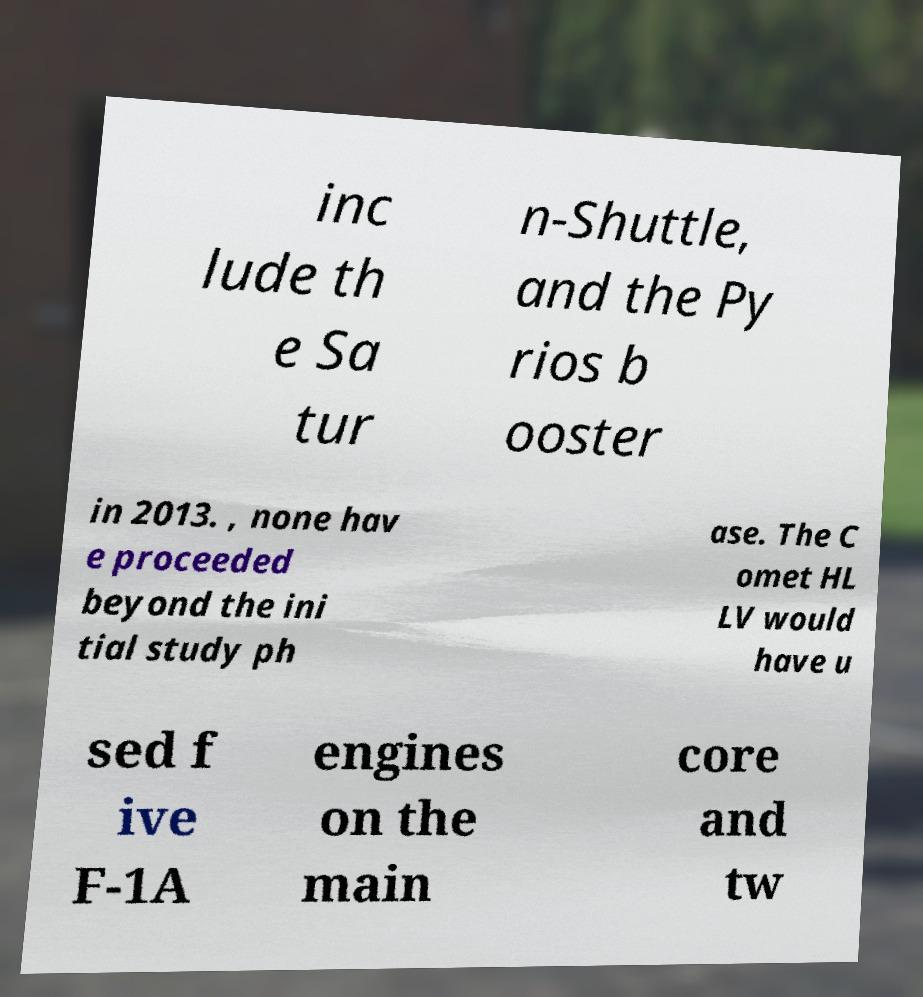I need the written content from this picture converted into text. Can you do that? inc lude th e Sa tur n-Shuttle, and the Py rios b ooster in 2013. , none hav e proceeded beyond the ini tial study ph ase. The C omet HL LV would have u sed f ive F-1A engines on the main core and tw 